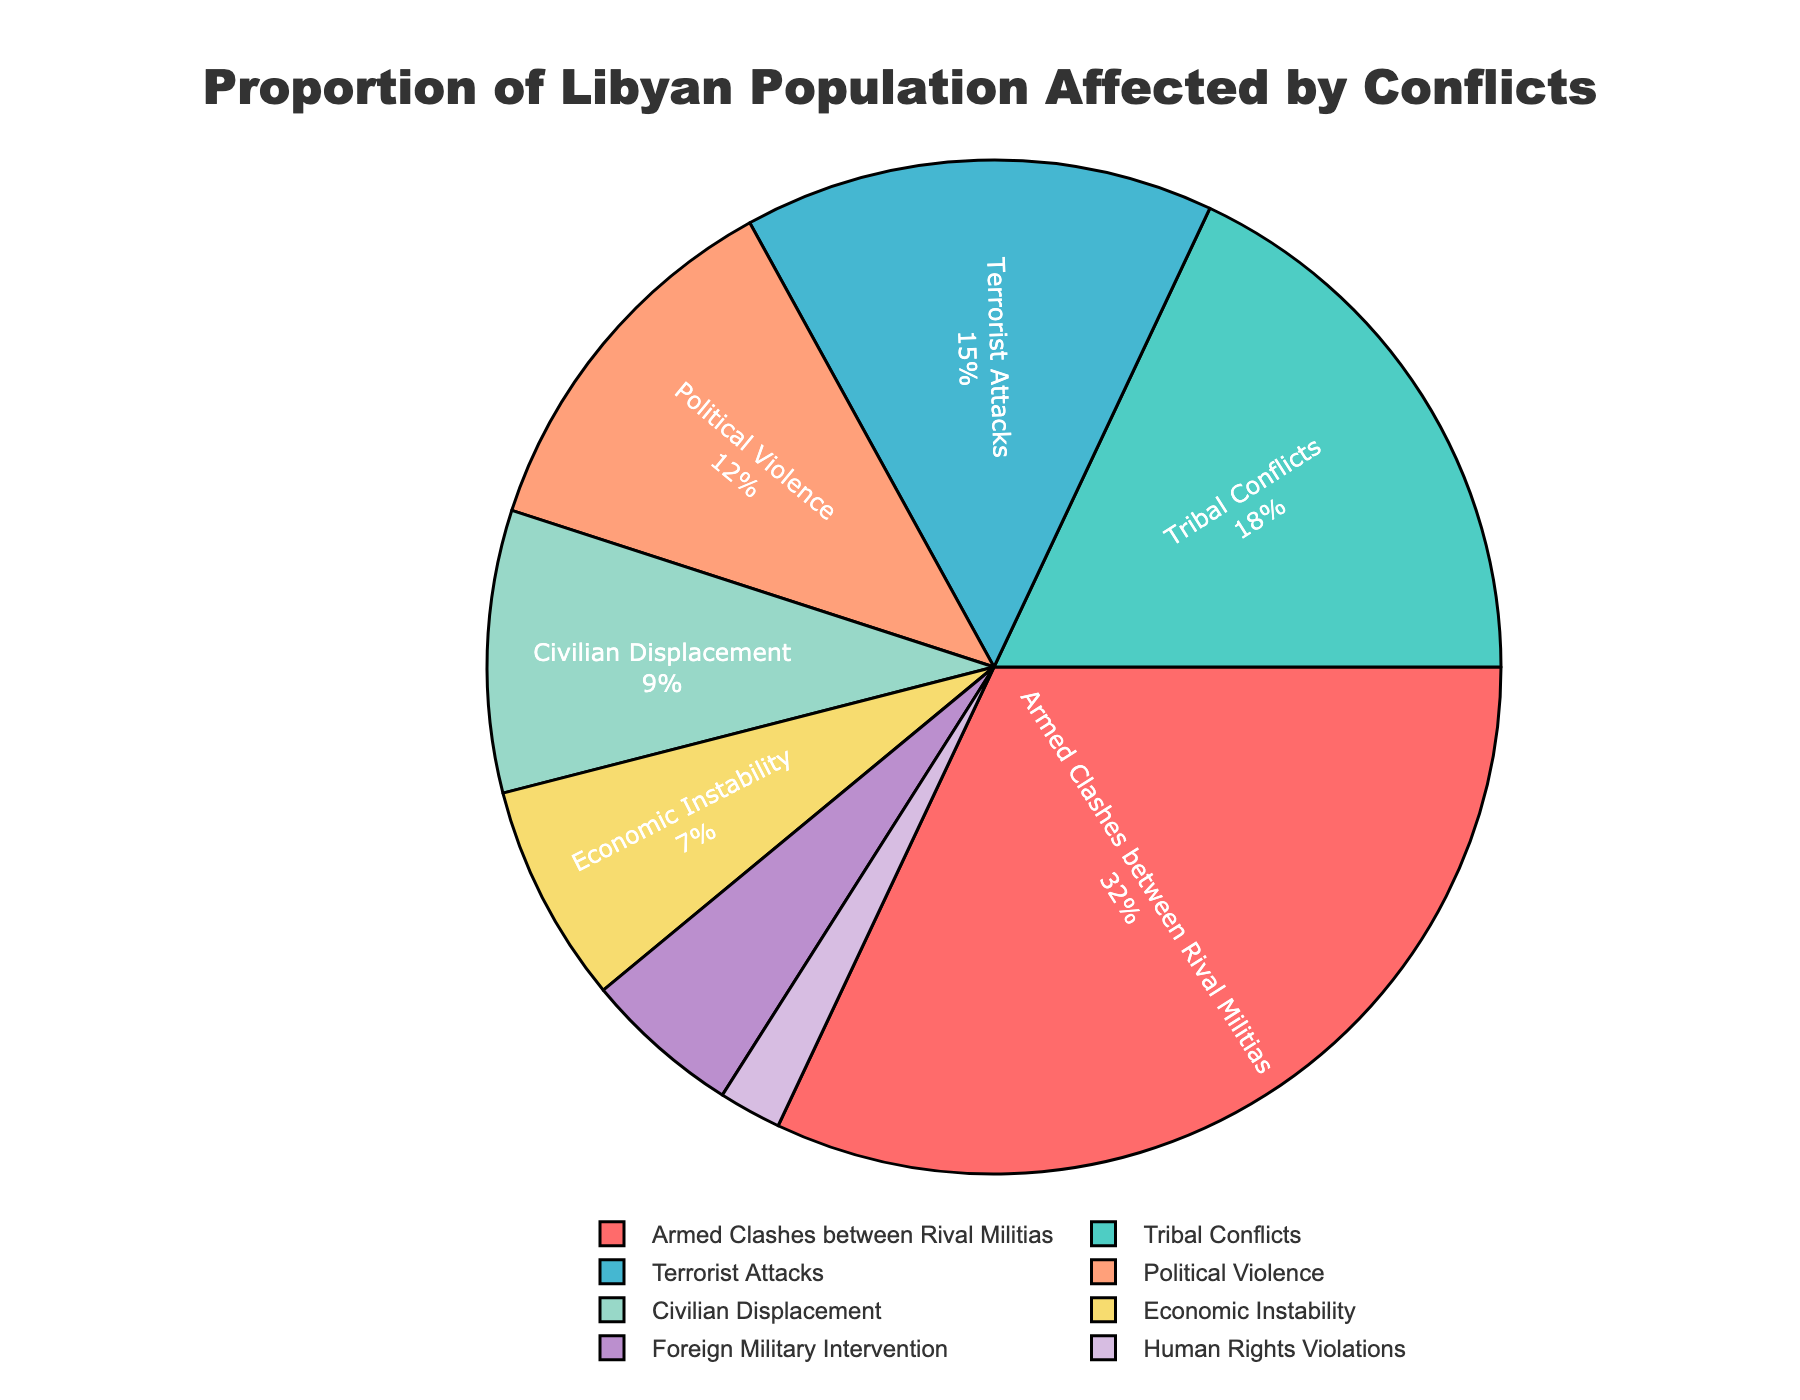Which type of conflict affects the largest proportion of the Libyan population? The pie chart shows various types of conflicts and their respective proportions. By looking at the largest segment, we see that "Armed Clashes between Rival Militias" has the highest proportion.
Answer: Armed Clashes between Rival Militias What percentage of the Libyan population is affected by tribal conflicts? The pie chart segments are labeled with conflict types and their percentages. The segment for "Tribal Conflicts" is marked 18%.
Answer: 18% Compare the impact of terrorist attacks with political violence. Which one affects a larger share of the population? By examining the pie chart, we notice that "Terrorist Attacks" affects 15% of the population, while "Political Violence" affects 12%. Therefore, "Terrorist Attacks" has a larger share.
Answer: Terrorist Attacks Calculate the total percentage of the population affected by political violence and economic instability. The pie chart shows political violence affects 12% and economic instability affects 7%. Adding these two percentages gives 12% + 7% = 19%.
Answer: 19% Which types of conflicts together affect less than 10% of the population? Based on the pie chart, conflicts affecting less than 10% include "Foreign Military Intervention" (5%) and "Human Rights Violations" (2%).
Answer: Foreign Military Intervention and Human Rights Violations What is the combined proportion of the population affected by tribal conflicts, terrorist attacks, and civilian displacement? From the pie chart: Tribal Conflicts affect 18%, Terrorist Attacks 15%, and Civilian Displacement 9%. Adding these gives 18% + 15% + 9% = 42%.
Answer: 42% What is the color of the pie chart segment representing foreign military intervention? The visual attributes of the chart show segments in different colors, and "Foreign Military Intervention" is represented in purple.
Answer: Purple Determine the difference in the percentage of the population affected by armed clashes between rival militias and humanitarian rights violations. Armed Clashes between Rival Militias affect 32%, and Human Rights Violations affect 2%. The difference is 32% - 2% = 30%.
Answer: 30% How many more people are affected by economic instability compared to foreign military intervention? Economic Instability affects 7% and Foreign Military Intervention 5%. The difference is 7% - 5% = 2%.
Answer: 2% Is the proportion of the population affected by terrorist attacks greater than the combined proportion affected by human rights violations and foreign military intervention? Terrorist Attacks affect 15%. Human Rights Violations and Foreign Military Intervention combined affect 2% + 5% = 7%. Since 15% > 7%, the proportion affected by terrorist attacks is indeed greater.
Answer: Yes 